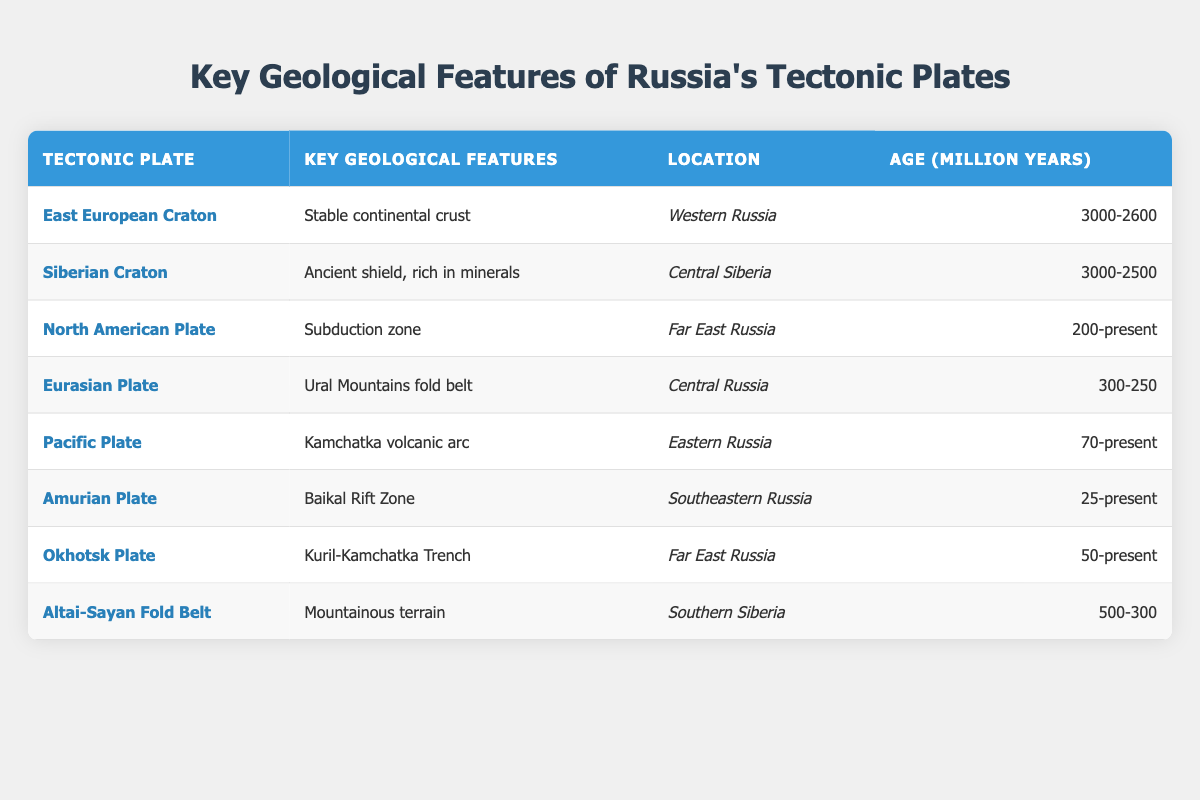What is the key geological feature of the East European Craton? The table shows that the East European Craton has the key geological feature of "Stable continental crust." This information is located in the second column of the row corresponding to the East European Craton.
Answer: Stable continental crust Which location is associated with the Siberian Craton? Referring to the table, the location associated with the Siberian Craton is "Central Siberia." This is found in the third column of the respective row.
Answer: Central Siberia Is the age of the Pacific Plate greater than 100 million years? By looking at the table, the Pacific Plate's age is listed as "70-present," indicating that it is less than 100 million years old because 70 million years is not greater than 100 million years.
Answer: No What are the ages of all the tectonic plates in million years? The ages provided in the table include: East European Craton (3000-2600), Siberian Craton (3000-2500), North American Plate (200-present), Eurasian Plate (300-250), Pacific Plate (70-present), Amurian Plate (25-present), Okhotsk Plate (50-present), and Altai-Sayan Fold Belt (500-300). To summarize, the ages span from 3000 million years to the present.
Answer: 3000-2600; 3000-2500; 200-present; 300-250; 70-present; 25-present; 50-present; 500-300 Which tectonic plate features the Baikal Rift Zone? The table indicates that the Amurian Plate features the Baikal Rift Zone as its key geological feature, found in the second column associated with the Amurian Plate row.
Answer: Amurian Plate What is the average age of the three oldest tectonic plates? The three oldest tectonic plates based on the ages are the East European Craton (3000-2600), Siberian Craton (3000-2500), and Altai-Sayan Fold Belt (500-300). Calculating the average involves taking the midpoint of the ages: (3000 + 2600 + 3000 + 2500 + 500 + 300)/6 = 1933.33 million years. Thus, the average age of these plates is approximately 1933 million years.
Answer: Approximately 1933 million years 